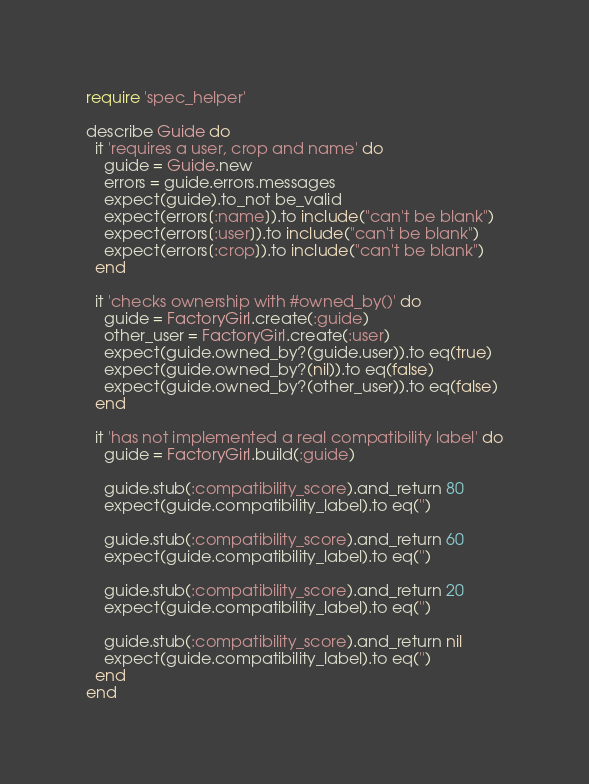Convert code to text. <code><loc_0><loc_0><loc_500><loc_500><_Ruby_>require 'spec_helper'

describe Guide do
  it 'requires a user, crop and name' do
    guide = Guide.new
    errors = guide.errors.messages
    expect(guide).to_not be_valid
    expect(errors[:name]).to include("can't be blank")
    expect(errors[:user]).to include("can't be blank")
    expect(errors[:crop]).to include("can't be blank")
  end

  it 'checks ownership with #owned_by()' do
    guide = FactoryGirl.create(:guide)
    other_user = FactoryGirl.create(:user)
    expect(guide.owned_by?(guide.user)).to eq(true)
    expect(guide.owned_by?(nil)).to eq(false)
    expect(guide.owned_by?(other_user)).to eq(false)
  end

  it 'has not implemented a real compatibility label' do
    guide = FactoryGirl.build(:guide)

    guide.stub(:compatibility_score).and_return 80
    expect(guide.compatibility_label).to eq('')

    guide.stub(:compatibility_score).and_return 60
    expect(guide.compatibility_label).to eq('')

    guide.stub(:compatibility_score).and_return 20
    expect(guide.compatibility_label).to eq('')

    guide.stub(:compatibility_score).and_return nil
    expect(guide.compatibility_label).to eq('')
  end
end
</code> 